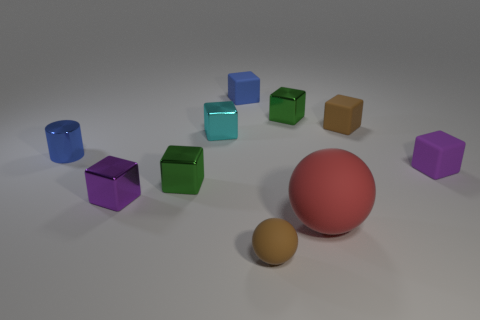How many large red objects are the same shape as the tiny blue rubber thing?
Give a very brief answer. 0. The cyan thing that is the same material as the tiny blue cylinder is what size?
Keep it short and to the point. Small. The small thing that is both in front of the tiny purple matte thing and right of the cyan cube is made of what material?
Your answer should be very brief. Rubber. How many cyan metal objects are the same size as the metallic cylinder?
Offer a very short reply. 1. There is another thing that is the same shape as the big red thing; what is its material?
Provide a succinct answer. Rubber. How many objects are tiny balls on the left side of the red matte thing or small metallic cubes that are in front of the cyan thing?
Offer a very short reply. 3. There is a small blue matte thing; does it have the same shape as the green object that is right of the cyan object?
Offer a very short reply. Yes. What shape is the brown thing that is in front of the small green metal block on the left side of the small brown thing that is left of the brown block?
Make the answer very short. Sphere. What number of other things are there of the same material as the tiny blue cylinder
Provide a succinct answer. 4. How many objects are green metal cubes left of the tiny blue rubber thing or red spheres?
Your response must be concise. 2. 